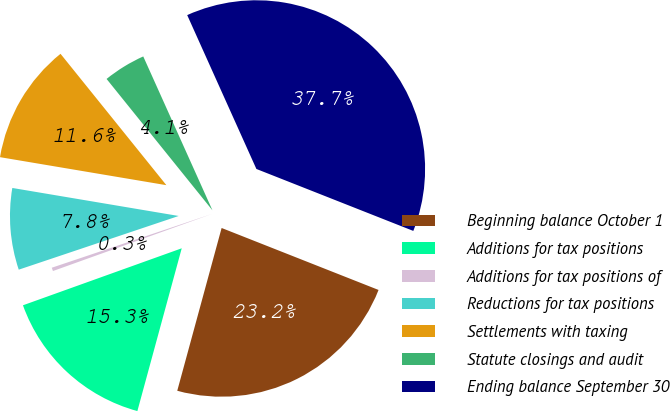Convert chart. <chart><loc_0><loc_0><loc_500><loc_500><pie_chart><fcel>Beginning balance October 1<fcel>Additions for tax positions<fcel>Additions for tax positions of<fcel>Reductions for tax positions<fcel>Settlements with taxing<fcel>Statute closings and audit<fcel>Ending balance September 30<nl><fcel>23.25%<fcel>15.28%<fcel>0.33%<fcel>7.81%<fcel>11.55%<fcel>4.07%<fcel>37.71%<nl></chart> 